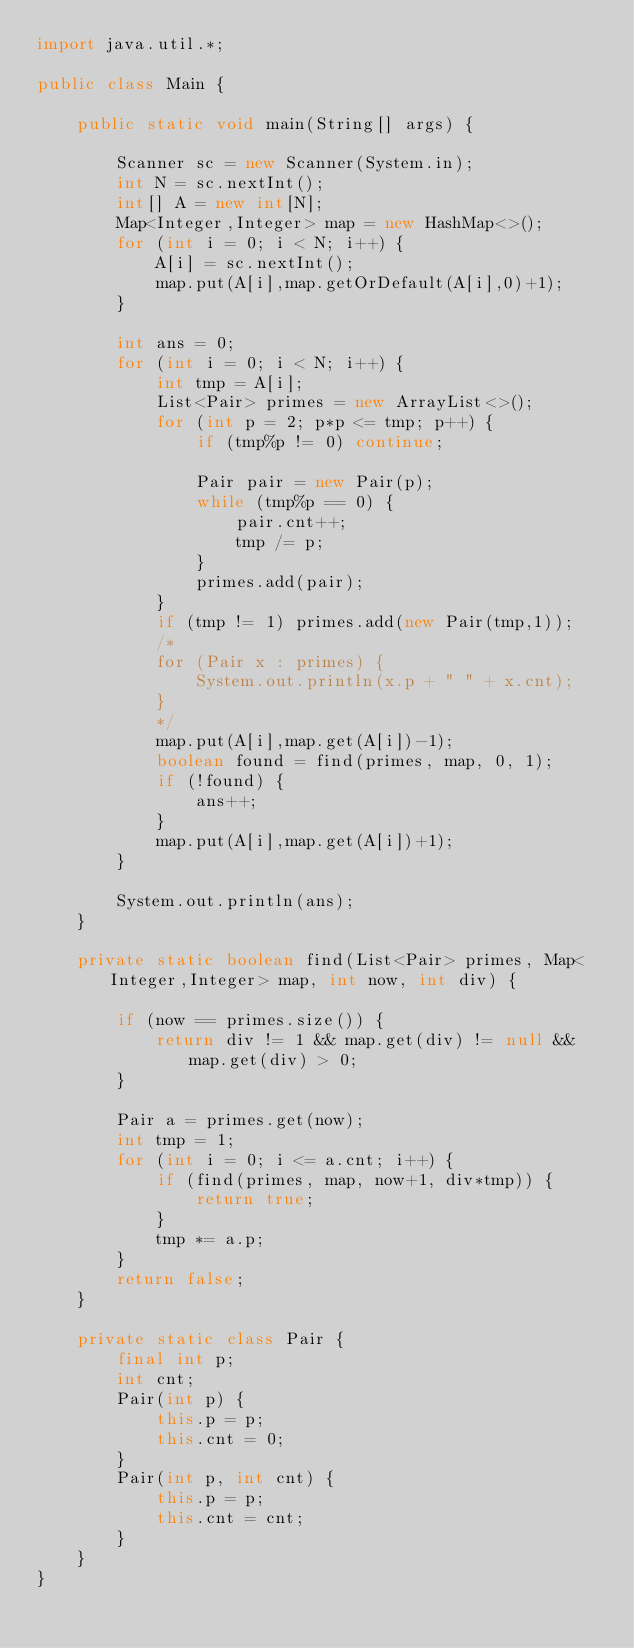<code> <loc_0><loc_0><loc_500><loc_500><_Java_>import java.util.*;

public class Main {

    public static void main(String[] args) {

        Scanner sc = new Scanner(System.in);
        int N = sc.nextInt();
        int[] A = new int[N];
        Map<Integer,Integer> map = new HashMap<>();
        for (int i = 0; i < N; i++) {
            A[i] = sc.nextInt();
            map.put(A[i],map.getOrDefault(A[i],0)+1);
        }

        int ans = 0;
        for (int i = 0; i < N; i++) {
            int tmp = A[i];
            List<Pair> primes = new ArrayList<>();
            for (int p = 2; p*p <= tmp; p++) {
                if (tmp%p != 0) continue;

                Pair pair = new Pair(p);
                while (tmp%p == 0) {
                    pair.cnt++;
                    tmp /= p;
                }
                primes.add(pair);
            }
            if (tmp != 1) primes.add(new Pair(tmp,1));
            /*
            for (Pair x : primes) {
                System.out.println(x.p + " " + x.cnt);
            }
            */
            map.put(A[i],map.get(A[i])-1);
            boolean found = find(primes, map, 0, 1);
            if (!found) {
                ans++;
            }
            map.put(A[i],map.get(A[i])+1);
        }

        System.out.println(ans);
    }

    private static boolean find(List<Pair> primes, Map<Integer,Integer> map, int now, int div) {

        if (now == primes.size()) {
            return div != 1 && map.get(div) != null && map.get(div) > 0;
        }

        Pair a = primes.get(now);
        int tmp = 1;
        for (int i = 0; i <= a.cnt; i++) {
            if (find(primes, map, now+1, div*tmp)) {
                return true;
            }
            tmp *= a.p;
        }
        return false;
    }

    private static class Pair {
        final int p;
        int cnt;
        Pair(int p) {
            this.p = p;
            this.cnt = 0;
        }
        Pair(int p, int cnt) {
            this.p = p;
            this.cnt = cnt;
        }
    }
}
</code> 